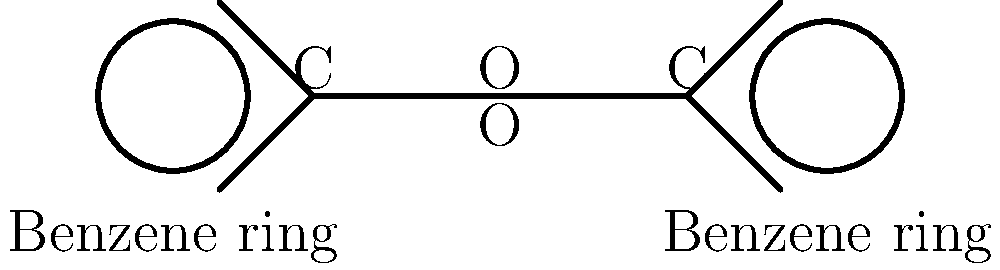In the chemical structure of benzoyl peroxide shown above, what is the functional group connecting the two benzene rings, and how many oxygen atoms does it contain? To answer this question, let's analyze the chemical structure step-by-step:

1. Identify the main components:
   - There are two benzene rings, one on each side of the molecule.
   - These rings are connected by a central group.

2. Examine the central group:
   - It consists of two carbon atoms (C) connected by a single bond.
   - Each carbon atom is also bonded to an oxygen atom (O).

3. Recognize the functional group:
   - The central group with the structure -COO- is called a peroxide group.
   - Specifically, it's a benzoyl peroxide because it's connected to benzene rings.

4. Count the oxygen atoms:
   - There are two oxygen atoms in the peroxide group, one connected to each carbon atom.

5. Conclude:
   - The functional group connecting the benzene rings is a peroxide group.
   - It contains 2 oxygen atoms.

This peroxide group is responsible for the effectiveness of benzoyl peroxide as an acne treatment, as it breaks down to release oxygen, which helps kill acne-causing bacteria.
Answer: Peroxide group; 2 oxygen atoms 